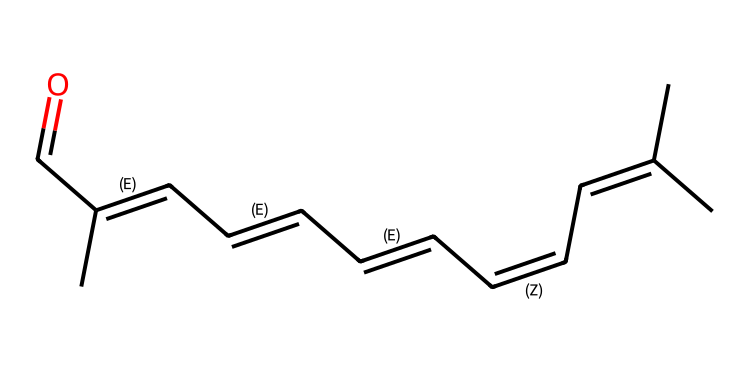What is the molecular formula of retinal? In the provided SMILES representation, we can count the carbon (C), hydrogen (H), and oxygen (O) atoms. There are 20 carbon atoms, 28 hydrogen atoms, and 1 oxygen atom. Thus, the molecular formula is obtained by combining these counts.
Answer: C20H28O How many double bonds are present in this molecule? By analyzing the SMILES structure, we can identify each "=C" segment that indicates a double bond. There are a total of 11 double bonds present in the retinal structure.
Answer: 11 Does retinal exhibit geometric isomerism? Geometric isomerism typically occurs due to restricted rotation around double bonds in molecules. Given the multiple double bonds in retinal's structure, it allows for different spatial arrangements (cis and trans configurations) which confirms the presence of geometric isomers.
Answer: Yes What functional group is present in the retinal molecule? Looking at the end of the provided SMILES, we notice the "C=O" segment indicates a carbonyl group, which is characteristic of aldehydes. This functional group is essential in the structure of retinal.
Answer: Aldehyde What is the importance of the geometric configuration in retinal's function? The geometric configuration (cis or trans) is crucial as it affects retinal's ability to absorb light. The cis form of retinal, when hit by light, undergoes a conformational change that triggers the visual signaling cascade; therefore, the geometric position directly influences its capacity for light perception.
Answer: Light perception Which geometric isomer of retinal is involved in the visual process? In the process of light perception, the cis isomer of retinal is the active form that undergoes structural changes upon absorbing photons, making it essential for vision.
Answer: Cis isomer 